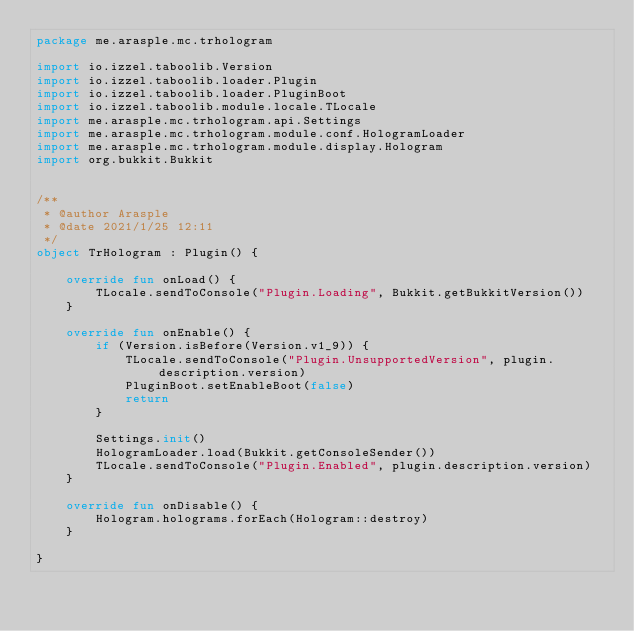<code> <loc_0><loc_0><loc_500><loc_500><_Kotlin_>package me.arasple.mc.trhologram

import io.izzel.taboolib.Version
import io.izzel.taboolib.loader.Plugin
import io.izzel.taboolib.loader.PluginBoot
import io.izzel.taboolib.module.locale.TLocale
import me.arasple.mc.trhologram.api.Settings
import me.arasple.mc.trhologram.module.conf.HologramLoader
import me.arasple.mc.trhologram.module.display.Hologram
import org.bukkit.Bukkit


/**
 * @author Arasple
 * @date 2021/1/25 12:11
 */
object TrHologram : Plugin() {

    override fun onLoad() {
        TLocale.sendToConsole("Plugin.Loading", Bukkit.getBukkitVersion())
    }

    override fun onEnable() {
        if (Version.isBefore(Version.v1_9)) {
            TLocale.sendToConsole("Plugin.UnsupportedVersion", plugin.description.version)
            PluginBoot.setEnableBoot(false)
            return
        }

        Settings.init()
        HologramLoader.load(Bukkit.getConsoleSender())
        TLocale.sendToConsole("Plugin.Enabled", plugin.description.version)
    }

    override fun onDisable() {
        Hologram.holograms.forEach(Hologram::destroy)
    }

}</code> 